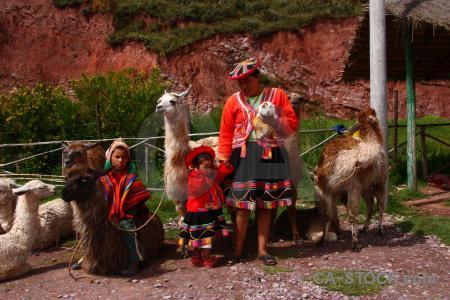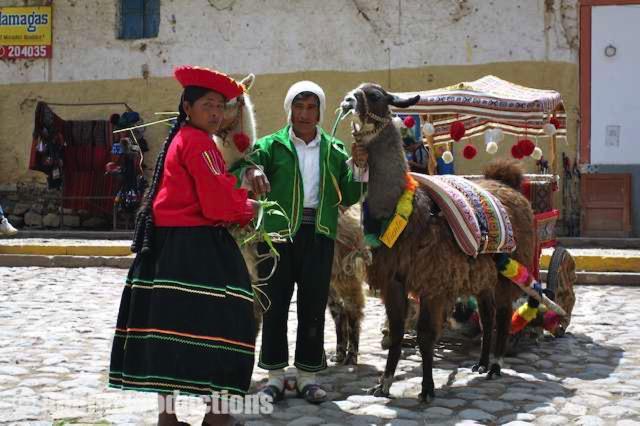The first image is the image on the left, the second image is the image on the right. Assess this claim about the two images: "The right image includes a person leading a llama toward the camera, and the left image includes multiple llamas wearing packs.". Correct or not? Answer yes or no. No. 